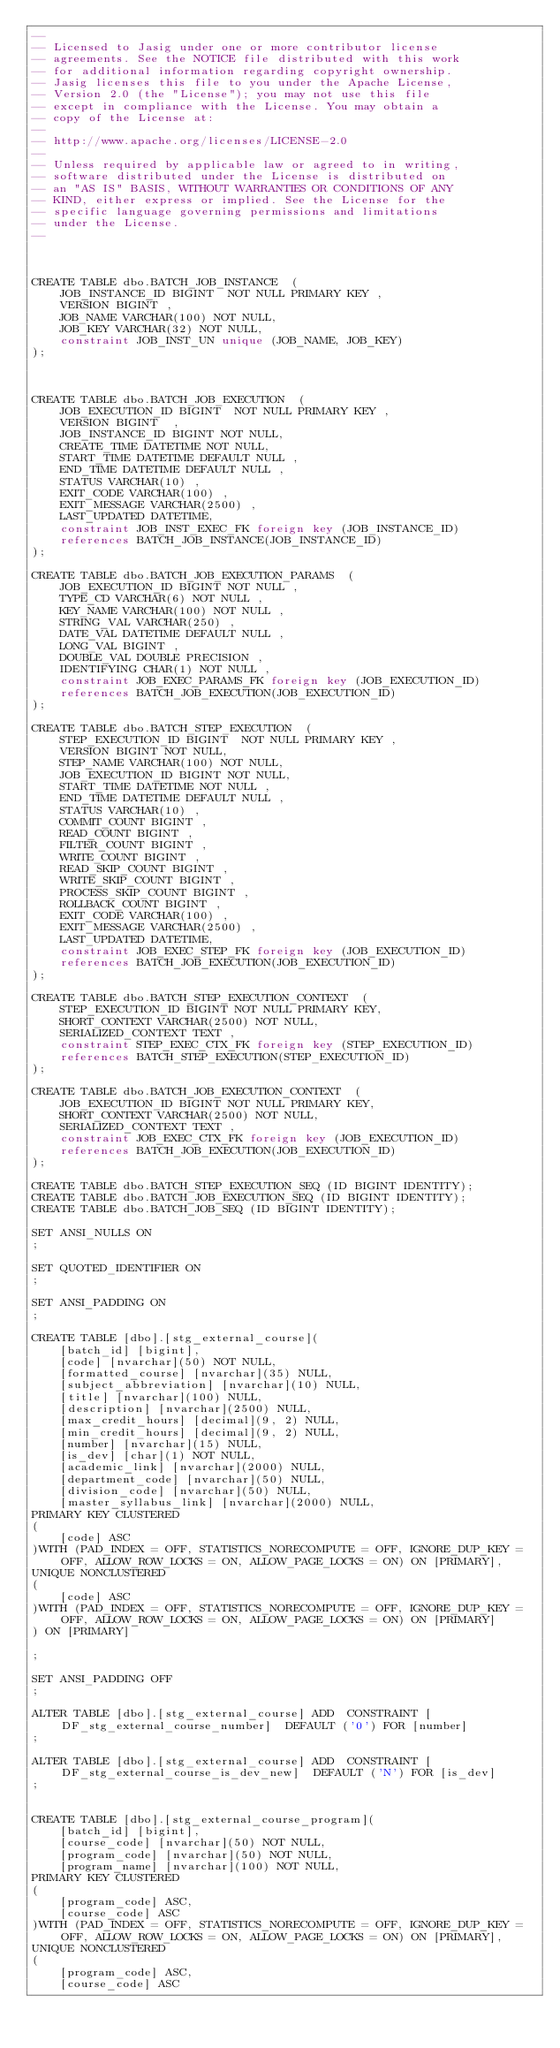<code> <loc_0><loc_0><loc_500><loc_500><_SQL_>--
-- Licensed to Jasig under one or more contributor license
-- agreements. See the NOTICE file distributed with this work
-- for additional information regarding copyright ownership.
-- Jasig licenses this file to you under the Apache License,
-- Version 2.0 (the "License"); you may not use this file
-- except in compliance with the License. You may obtain a
-- copy of the License at:
--
-- http://www.apache.org/licenses/LICENSE-2.0
--
-- Unless required by applicable law or agreed to in writing,
-- software distributed under the License is distributed on
-- an "AS IS" BASIS, WITHOUT WARRANTIES OR CONDITIONS OF ANY
-- KIND, either express or implied. See the License for the
-- specific language governing permissions and limitations
-- under the License.
--



CREATE TABLE dbo.BATCH_JOB_INSTANCE  (
    JOB_INSTANCE_ID BIGINT  NOT NULL PRIMARY KEY ,
    VERSION BIGINT ,
    JOB_NAME VARCHAR(100) NOT NULL,
    JOB_KEY VARCHAR(32) NOT NULL,
    constraint JOB_INST_UN unique (JOB_NAME, JOB_KEY)
);



CREATE TABLE dbo.BATCH_JOB_EXECUTION  (
    JOB_EXECUTION_ID BIGINT  NOT NULL PRIMARY KEY ,
    VERSION BIGINT  ,
    JOB_INSTANCE_ID BIGINT NOT NULL,
    CREATE_TIME DATETIME NOT NULL,
    START_TIME DATETIME DEFAULT NULL ,
    END_TIME DATETIME DEFAULT NULL ,
    STATUS VARCHAR(10) ,
    EXIT_CODE VARCHAR(100) ,
    EXIT_MESSAGE VARCHAR(2500) ,
    LAST_UPDATED DATETIME,
    constraint JOB_INST_EXEC_FK foreign key (JOB_INSTANCE_ID)
    references BATCH_JOB_INSTANCE(JOB_INSTANCE_ID)
);

CREATE TABLE dbo.BATCH_JOB_EXECUTION_PARAMS  (
    JOB_EXECUTION_ID BIGINT NOT NULL ,
    TYPE_CD VARCHAR(6) NOT NULL ,
    KEY_NAME VARCHAR(100) NOT NULL ,
    STRING_VAL VARCHAR(250) ,
    DATE_VAL DATETIME DEFAULT NULL ,
    LONG_VAL BIGINT ,
    DOUBLE_VAL DOUBLE PRECISION ,
    IDENTIFYING CHAR(1) NOT NULL ,
    constraint JOB_EXEC_PARAMS_FK foreign key (JOB_EXECUTION_ID)
    references BATCH_JOB_EXECUTION(JOB_EXECUTION_ID)
);

CREATE TABLE dbo.BATCH_STEP_EXECUTION  (
    STEP_EXECUTION_ID BIGINT  NOT NULL PRIMARY KEY ,
    VERSION BIGINT NOT NULL,
    STEP_NAME VARCHAR(100) NOT NULL,
    JOB_EXECUTION_ID BIGINT NOT NULL,
    START_TIME DATETIME NOT NULL ,
    END_TIME DATETIME DEFAULT NULL ,
    STATUS VARCHAR(10) ,
    COMMIT_COUNT BIGINT ,
    READ_COUNT BIGINT ,
    FILTER_COUNT BIGINT ,
    WRITE_COUNT BIGINT ,
    READ_SKIP_COUNT BIGINT ,
    WRITE_SKIP_COUNT BIGINT ,
    PROCESS_SKIP_COUNT BIGINT ,
    ROLLBACK_COUNT BIGINT ,
    EXIT_CODE VARCHAR(100) ,
    EXIT_MESSAGE VARCHAR(2500) ,
    LAST_UPDATED DATETIME,
    constraint JOB_EXEC_STEP_FK foreign key (JOB_EXECUTION_ID)
    references BATCH_JOB_EXECUTION(JOB_EXECUTION_ID)
);

CREATE TABLE dbo.BATCH_STEP_EXECUTION_CONTEXT  (
    STEP_EXECUTION_ID BIGINT NOT NULL PRIMARY KEY,
    SHORT_CONTEXT VARCHAR(2500) NOT NULL,
    SERIALIZED_CONTEXT TEXT ,
    constraint STEP_EXEC_CTX_FK foreign key (STEP_EXECUTION_ID)
    references BATCH_STEP_EXECUTION(STEP_EXECUTION_ID)
);

CREATE TABLE dbo.BATCH_JOB_EXECUTION_CONTEXT  (
    JOB_EXECUTION_ID BIGINT NOT NULL PRIMARY KEY,
    SHORT_CONTEXT VARCHAR(2500) NOT NULL,
    SERIALIZED_CONTEXT TEXT ,
    constraint JOB_EXEC_CTX_FK foreign key (JOB_EXECUTION_ID)
    references BATCH_JOB_EXECUTION(JOB_EXECUTION_ID)
);

CREATE TABLE dbo.BATCH_STEP_EXECUTION_SEQ (ID BIGINT IDENTITY);
CREATE TABLE dbo.BATCH_JOB_EXECUTION_SEQ (ID BIGINT IDENTITY);
CREATE TABLE dbo.BATCH_JOB_SEQ (ID BIGINT IDENTITY);

SET ANSI_NULLS ON
;

SET QUOTED_IDENTIFIER ON
;

SET ANSI_PADDING ON
;

CREATE TABLE [dbo].[stg_external_course](
    [batch_id] [bigint],
    [code] [nvarchar](50) NOT NULL,
    [formatted_course] [nvarchar](35) NULL,
    [subject_abbreviation] [nvarchar](10) NULL,
    [title] [nvarchar](100) NULL,
    [description] [nvarchar](2500) NULL,
    [max_credit_hours] [decimal](9, 2) NULL,
    [min_credit_hours] [decimal](9, 2) NULL,
    [number] [nvarchar](15) NULL,
    [is_dev] [char](1) NOT NULL,
    [academic_link] [nvarchar](2000) NULL,
    [department_code] [nvarchar](50) NULL,
    [division_code] [nvarchar](50) NULL,
    [master_syllabus_link] [nvarchar](2000) NULL,
PRIMARY KEY CLUSTERED
(
    [code] ASC
)WITH (PAD_INDEX = OFF, STATISTICS_NORECOMPUTE = OFF, IGNORE_DUP_KEY = OFF, ALLOW_ROW_LOCKS = ON, ALLOW_PAGE_LOCKS = ON) ON [PRIMARY],
UNIQUE NONCLUSTERED
(
    [code] ASC
)WITH (PAD_INDEX = OFF, STATISTICS_NORECOMPUTE = OFF, IGNORE_DUP_KEY = OFF, ALLOW_ROW_LOCKS = ON, ALLOW_PAGE_LOCKS = ON) ON [PRIMARY]
) ON [PRIMARY]

;

SET ANSI_PADDING OFF
;

ALTER TABLE [dbo].[stg_external_course] ADD  CONSTRAINT [DF_stg_external_course_number]  DEFAULT ('0') FOR [number]
;

ALTER TABLE [dbo].[stg_external_course] ADD  CONSTRAINT [DF_stg_external_course_is_dev_new]  DEFAULT ('N') FOR [is_dev]
;


CREATE TABLE [dbo].[stg_external_course_program](
    [batch_id] [bigint],
    [course_code] [nvarchar](50) NOT NULL,
    [program_code] [nvarchar](50) NOT NULL,
    [program_name] [nvarchar](100) NOT NULL,
PRIMARY KEY CLUSTERED
(
    [program_code] ASC,
    [course_code] ASC
)WITH (PAD_INDEX = OFF, STATISTICS_NORECOMPUTE = OFF, IGNORE_DUP_KEY = OFF, ALLOW_ROW_LOCKS = ON, ALLOW_PAGE_LOCKS = ON) ON [PRIMARY],
UNIQUE NONCLUSTERED
(
    [program_code] ASC,
    [course_code] ASC</code> 